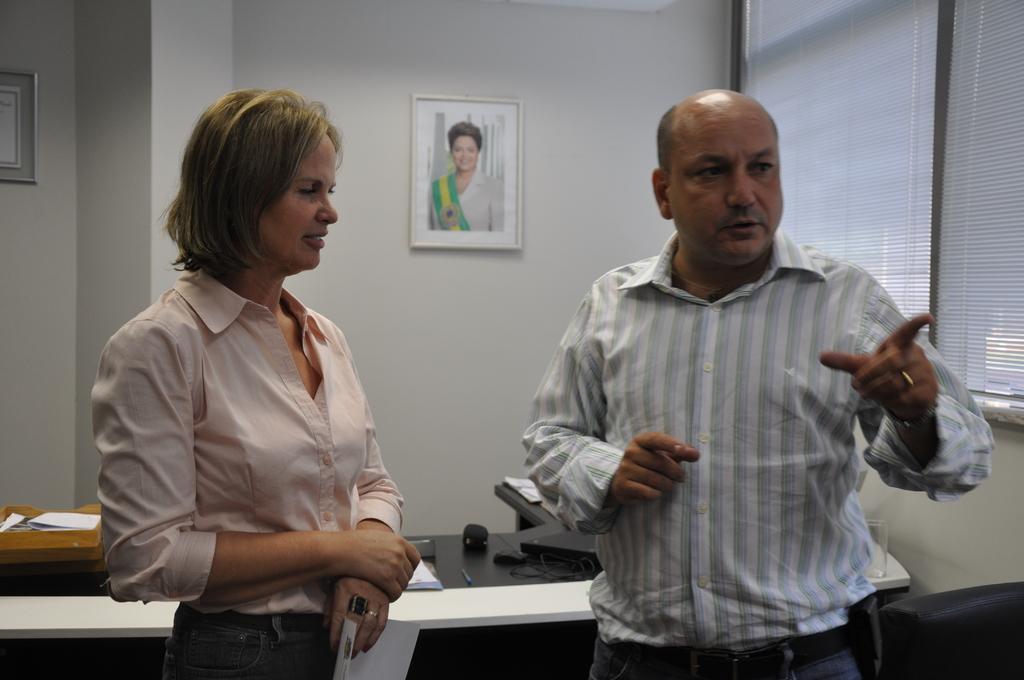In one or two sentences, can you explain what this image depicts? In this image, we can see people standing and one of them is holding a paper. In the background, there are frames on the wall and we can see a window and there is a box, papers, mouse, glass and some other objects are on the table and we can see a black color object. 